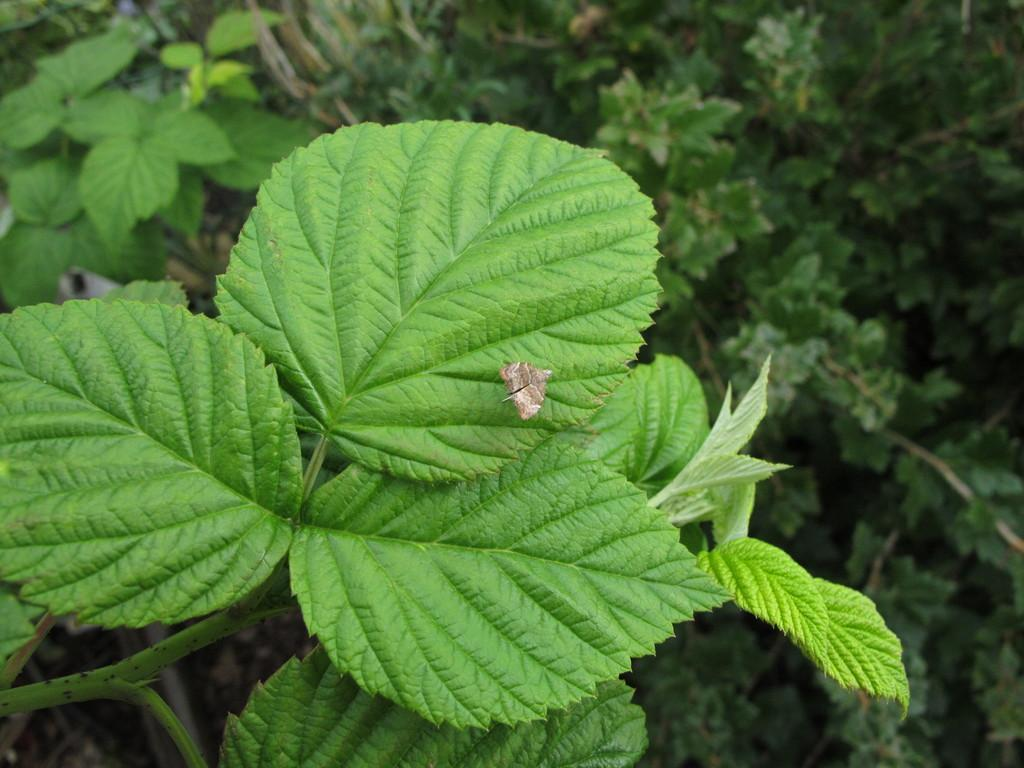What is present on the plant in the image? There is an insect on a plant in the image. What else can be seen in the background of the image? There are plants visible in the background of the image. What type of crate is holding the silk in the image? There is no crate or silk present in the image; it features an insect on a plant and other plants in the background. 